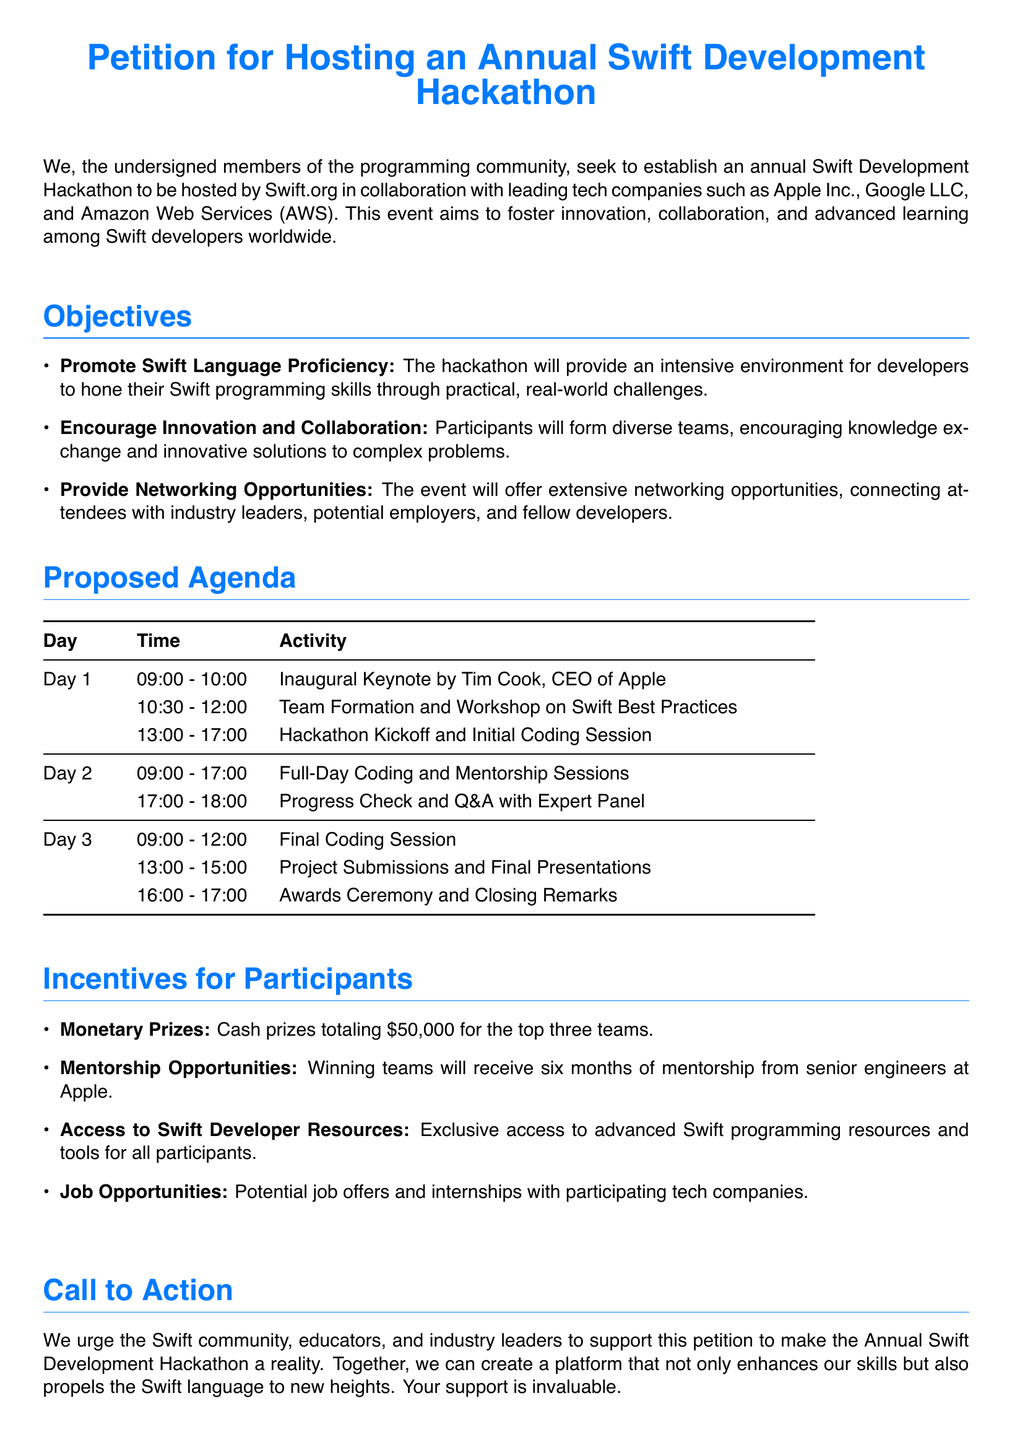What is the total cash prize for the hackathon? The total cash prize of the hackathon is stated as $50,000 for the top three teams.
Answer: $50,000 Who delivers the inaugural keynote? The document specifies that the inaugural keynote is delivered by Tim Cook, the CEO of Apple.
Answer: Tim Cook What day does the hackathon kickoff? The document mentions that the hackathon kickoff occurs on Day 1.
Answer: Day 1 How many days will the hackathon take place? The agenda outlines activities over three different days.
Answer: 3 days What is one of the objectives of the hackathon? The document lists objectives, including promoting Swift language proficiency among participants.
Answer: Promote Swift Language Proficiency What opportunity is offered to winning teams? The document states winning teams will receive mentorship opportunities from senior engineers at Apple.
Answer: Mentorship Opportunities What time does Day 2's coding sessions start? The agenda indicates that Day 2's coding sessions start at 09:00 AM.
Answer: 09:00 What is the purpose of the petition? The petition's purpose is to establish an annual Swift Development Hackathon supported by the Swift community and industry leaders.
Answer: Establish an annual Swift Development Hackathon What is included in participant incentives? The document provides details on incentives, including access to Swift developer resources for all participants.
Answer: Access to Swift Developer Resources 